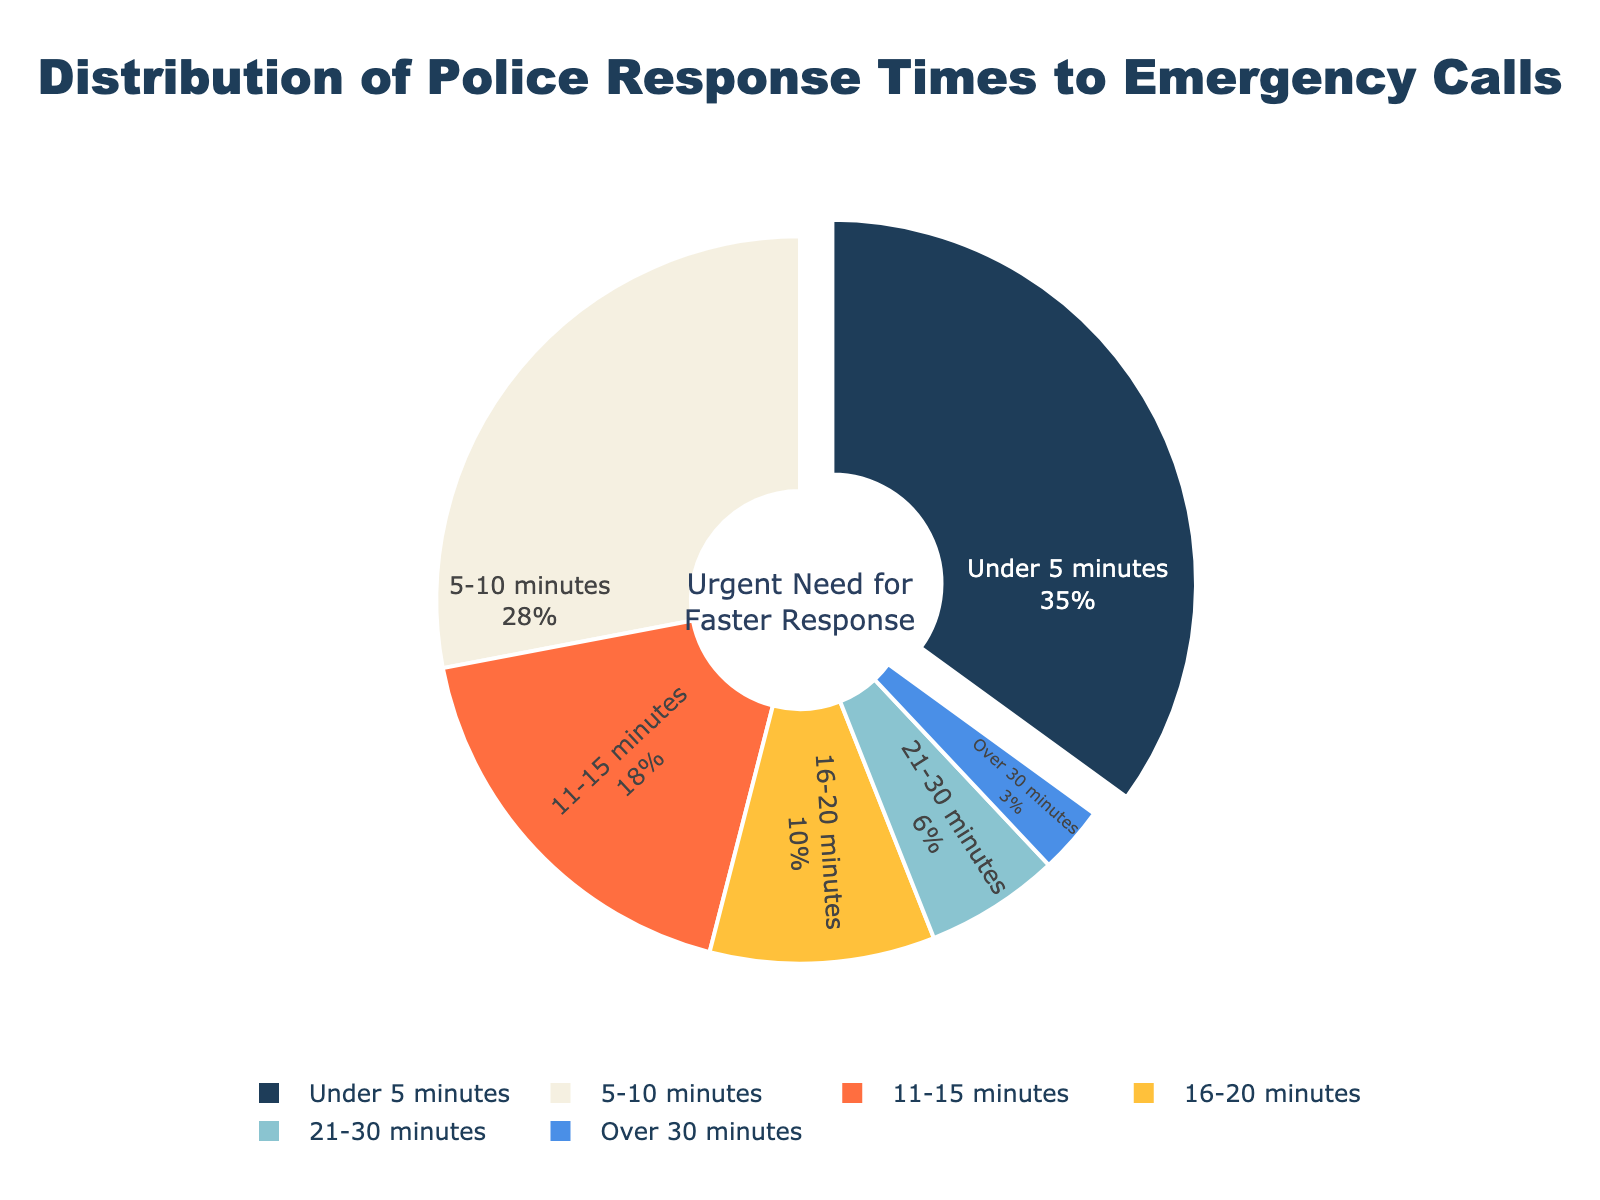Which response time category has the highest percentage? The figure shows a pie chart with segment sizes representing different response time categories. The segment labeled "Under 5 minutes" has the largest size, indicating it has the highest percentage.
Answer: Under 5 minutes How many response time categories have a percentage greater than or equal to 10%? By examining the pie chart, we can see that the categories "Under 5 minutes," "5-10 minutes," "11-15 minutes," and "16-20 minutes" each have segments that represent 35%, 28%, 18%, and 10%, respectively. There are 4 such categories.
Answer: 4 What is the combined percentage of response times between 5 and 15 minutes? The categories "5-10 minutes" and "11-15 minutes" fall within this range. Adding their percentages together, we get 28% + 18%, which equals 46%.
Answer: 46% Which response time category has the smallest percentage? The pie chart shows that the segment labeled "Over 30 minutes" has the smallest size, indicating it has the smallest percentage.
Answer: Over 30 minutes Is the percentage for "Under 5 minutes" greater than the combined percentage of "16-20 minutes" and "21-30 minutes"? The "Under 5 minutes" category has 35%. The combined percentage of "16-20 minutes" and "21-30 minutes" is 10% + 6% = 16%. Since 35% is greater than 16%, the answer is yes.
Answer: Yes What visual feature highlights the "Under 5 minutes" category? The "Under 5 minutes" category is visually distinguished by being slightly pulled out from the rest of the pie, which draws attention to it.
Answer: Pulled out segment By how much does the percentage of "Under 5 minutes" exceed that of "11-15 minutes"? The percentage for "Under 5 minutes" is 35%, and for "11-15 minutes" it is 18%. The difference is 35% - 18% = 17%.
Answer: 17% Which percentage is higher: the combined percentage of "21-30 minutes" and "Over 30 minutes" or the "16-20 minutes" category? The combined percentage of "21-30 minutes" and "Over 30 minutes" is 6% + 3% = 9%. The "16-20 minutes" category is 10%. Since 10% is greater than 9%, the "16-20 minutes" category has a higher percentage.
Answer: 16-20 minutes Identify the categories with their segments colored in shades of blue. The pie chart uses different colors for segments. The "Under 5 minutes" (dark blue) and "16-20 minutes" (light blue) categories are colored in shades of blue.
Answer: Under 5 minutes and 16-20 minutes 